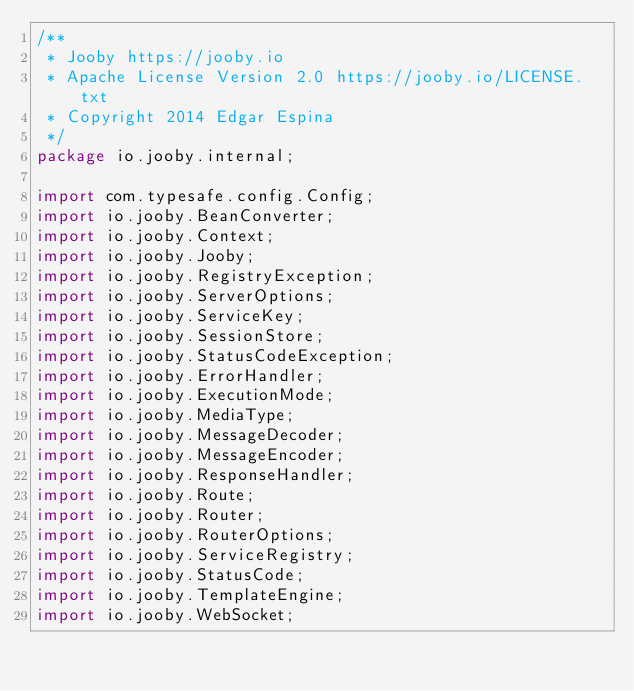Convert code to text. <code><loc_0><loc_0><loc_500><loc_500><_Java_>/**
 * Jooby https://jooby.io
 * Apache License Version 2.0 https://jooby.io/LICENSE.txt
 * Copyright 2014 Edgar Espina
 */
package io.jooby.internal;

import com.typesafe.config.Config;
import io.jooby.BeanConverter;
import io.jooby.Context;
import io.jooby.Jooby;
import io.jooby.RegistryException;
import io.jooby.ServerOptions;
import io.jooby.ServiceKey;
import io.jooby.SessionStore;
import io.jooby.StatusCodeException;
import io.jooby.ErrorHandler;
import io.jooby.ExecutionMode;
import io.jooby.MediaType;
import io.jooby.MessageDecoder;
import io.jooby.MessageEncoder;
import io.jooby.ResponseHandler;
import io.jooby.Route;
import io.jooby.Router;
import io.jooby.RouterOptions;
import io.jooby.ServiceRegistry;
import io.jooby.StatusCode;
import io.jooby.TemplateEngine;
import io.jooby.WebSocket;</code> 